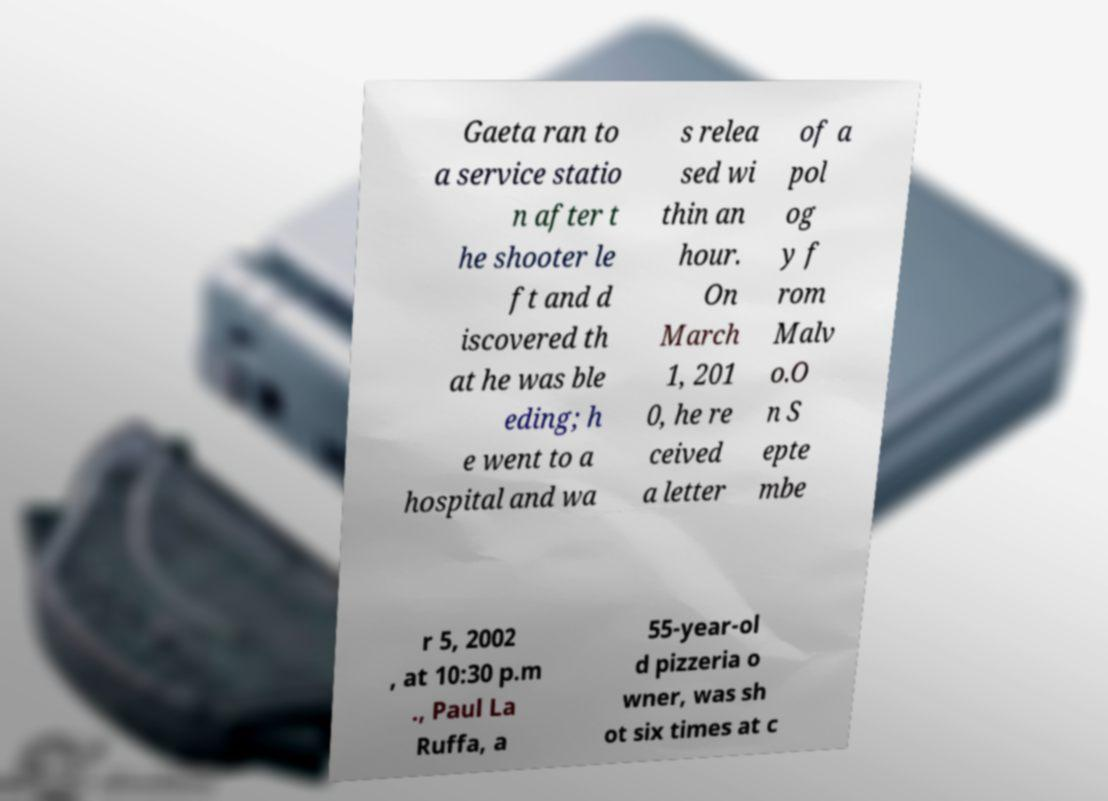There's text embedded in this image that I need extracted. Can you transcribe it verbatim? Gaeta ran to a service statio n after t he shooter le ft and d iscovered th at he was ble eding; h e went to a hospital and wa s relea sed wi thin an hour. On March 1, 201 0, he re ceived a letter of a pol og y f rom Malv o.O n S epte mbe r 5, 2002 , at 10:30 p.m ., Paul La Ruffa, a 55-year-ol d pizzeria o wner, was sh ot six times at c 